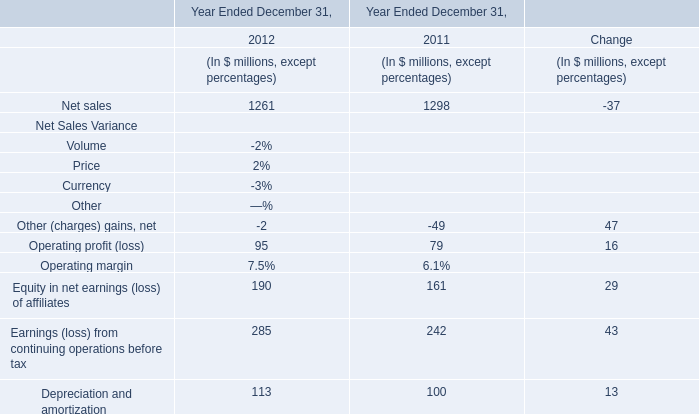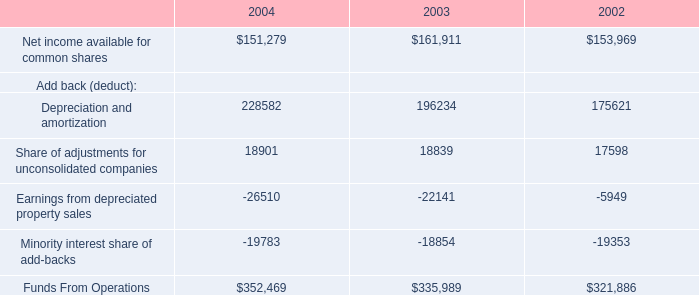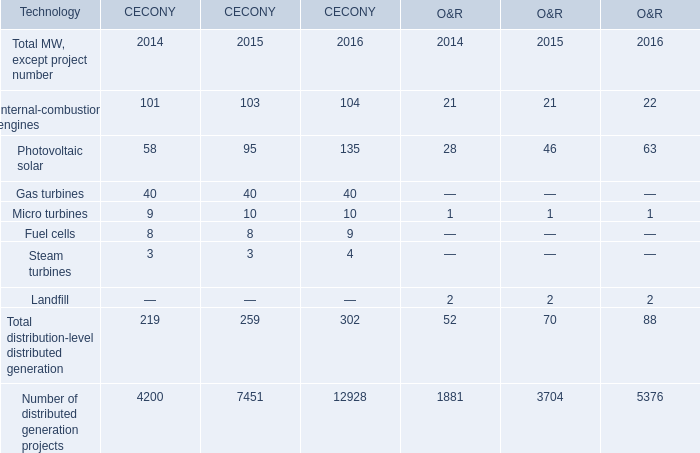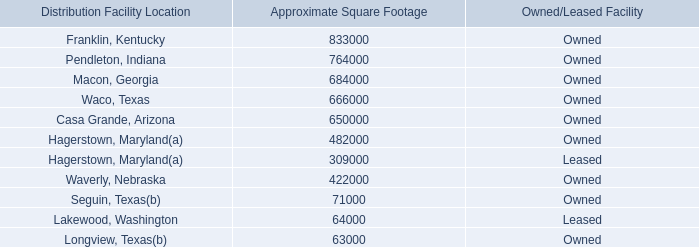What is the ratio of Internal-combustion engines to the total in 2014? 
Computations: ((101 + 21) / (219 + 52))
Answer: 0.45018. 